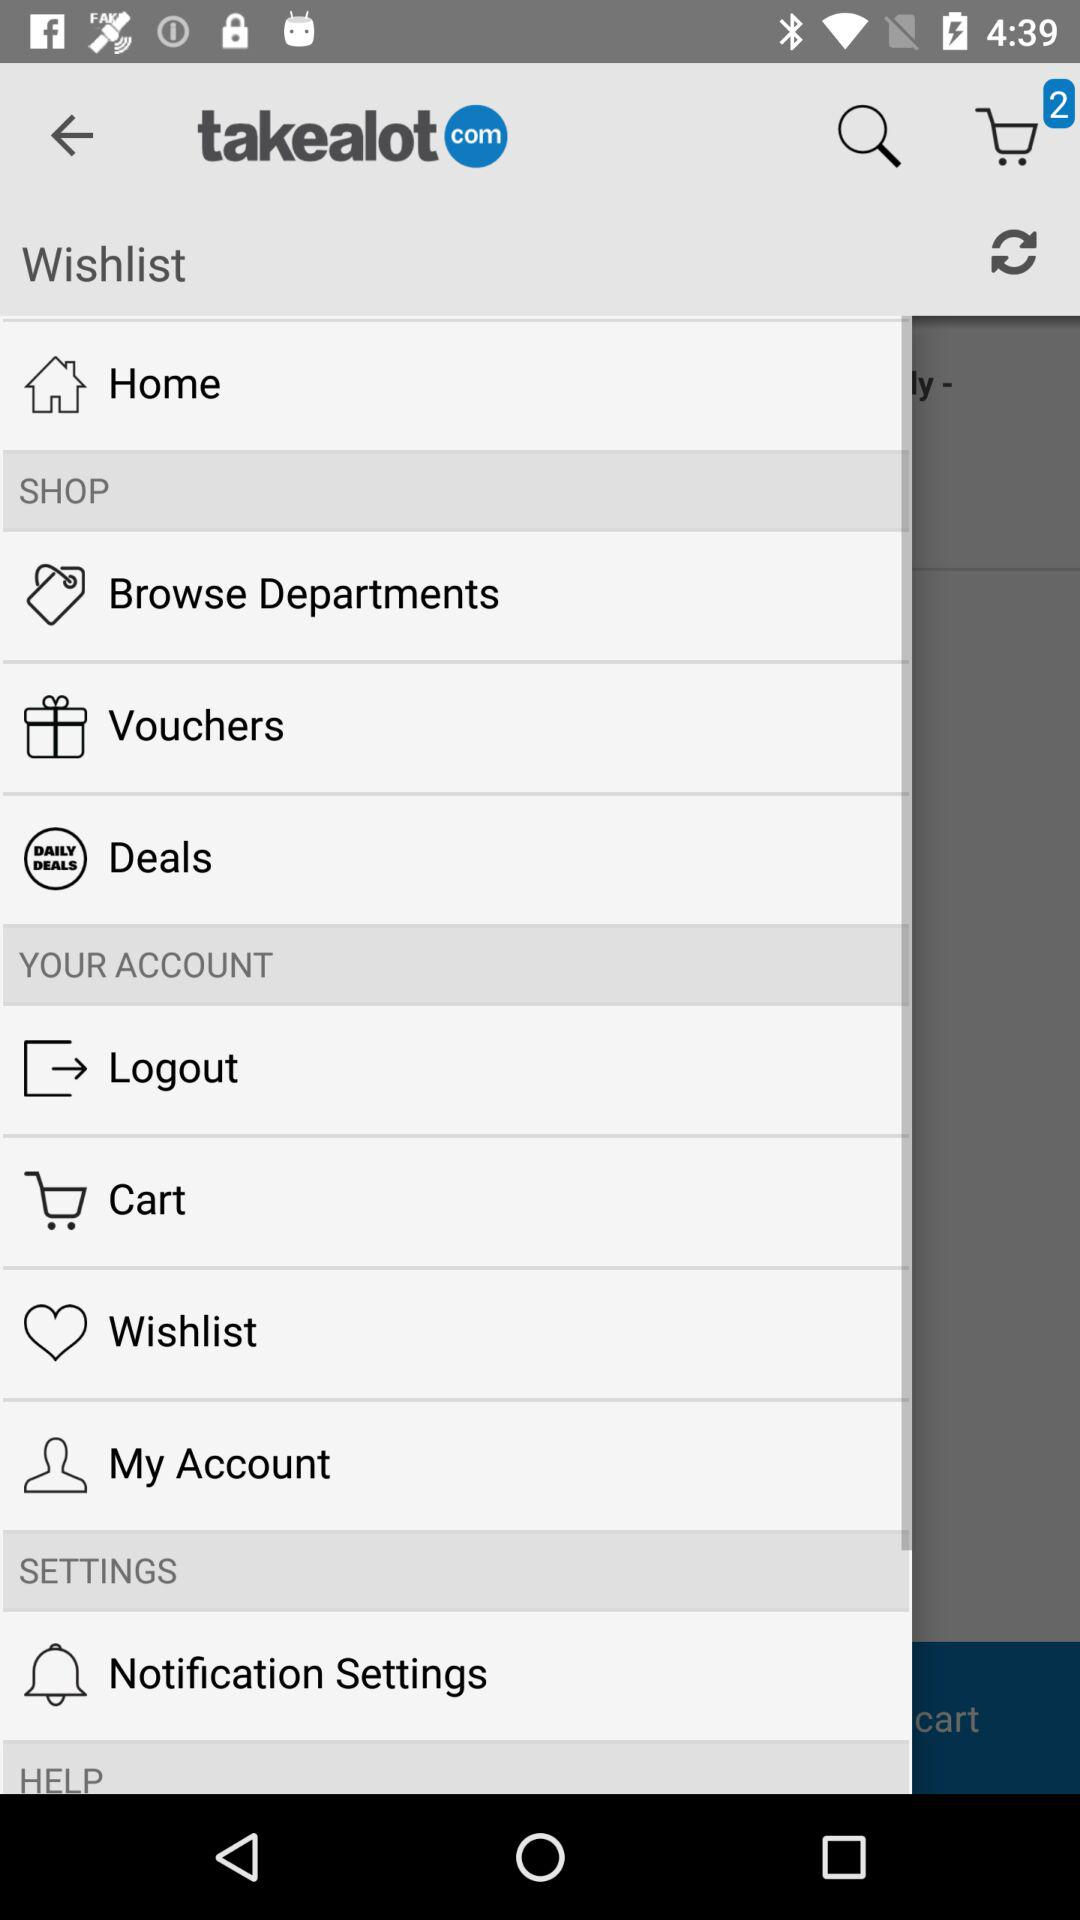How many items are available in the cart? There are 2 available items in the cart. 